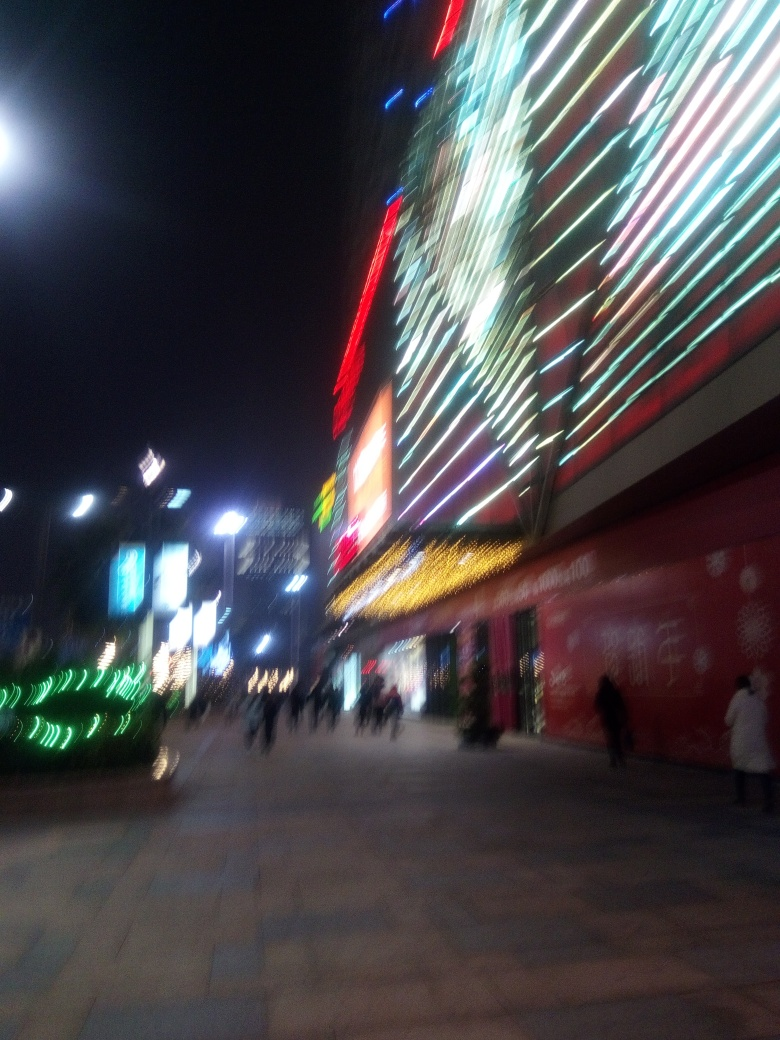What kind of establishments or businesses might be in the brightly lit buildings? The brightly lit buildings are indicative of commercial establishments, possibly including retail stores, restaurants, or entertainment venues. The vibrant lighting patterns and colors are often used to attract attention and suggest that these are places of leisure and commerce. 